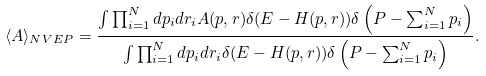<formula> <loc_0><loc_0><loc_500><loc_500>\langle A \rangle _ { N V E { P } } = \frac { \int \prod _ { i = 1 } ^ { N } d { p } _ { i } d { r } _ { i } A ( { p } , { r } ) \delta ( E - H ( { p } , { r } ) ) \delta \left ( { P } - \sum _ { i = 1 } ^ { N } { p } _ { i } \right ) } { \int \prod _ { i = 1 } ^ { N } d { p } _ { i } d { r } _ { i } \delta ( E - H ( { p } , { r } ) ) \delta \left ( { P } - \sum _ { i = 1 } ^ { N } { p } _ { i } \right ) } .</formula> 